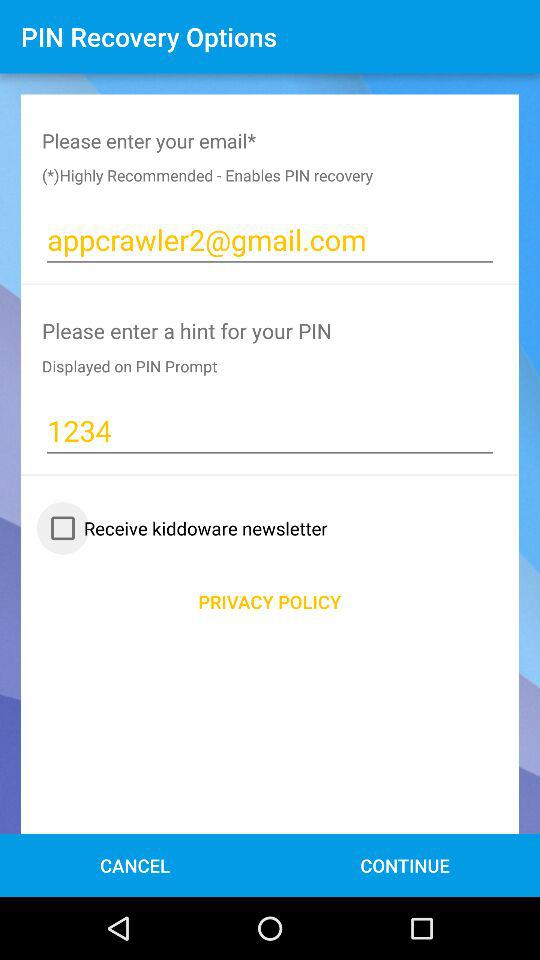What is the email address? The email address is appcrawler2@gmail.com. 